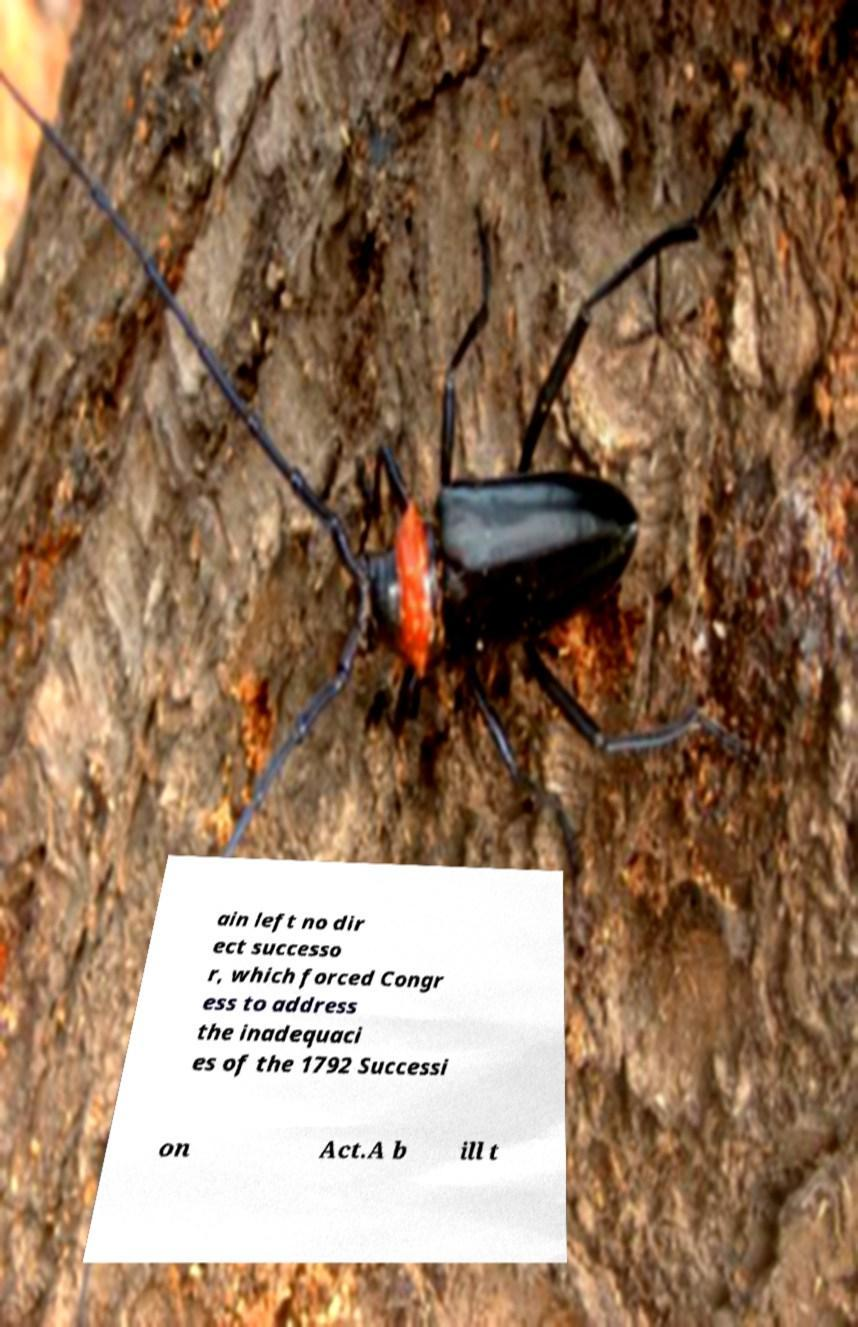There's text embedded in this image that I need extracted. Can you transcribe it verbatim? ain left no dir ect successo r, which forced Congr ess to address the inadequaci es of the 1792 Successi on Act.A b ill t 